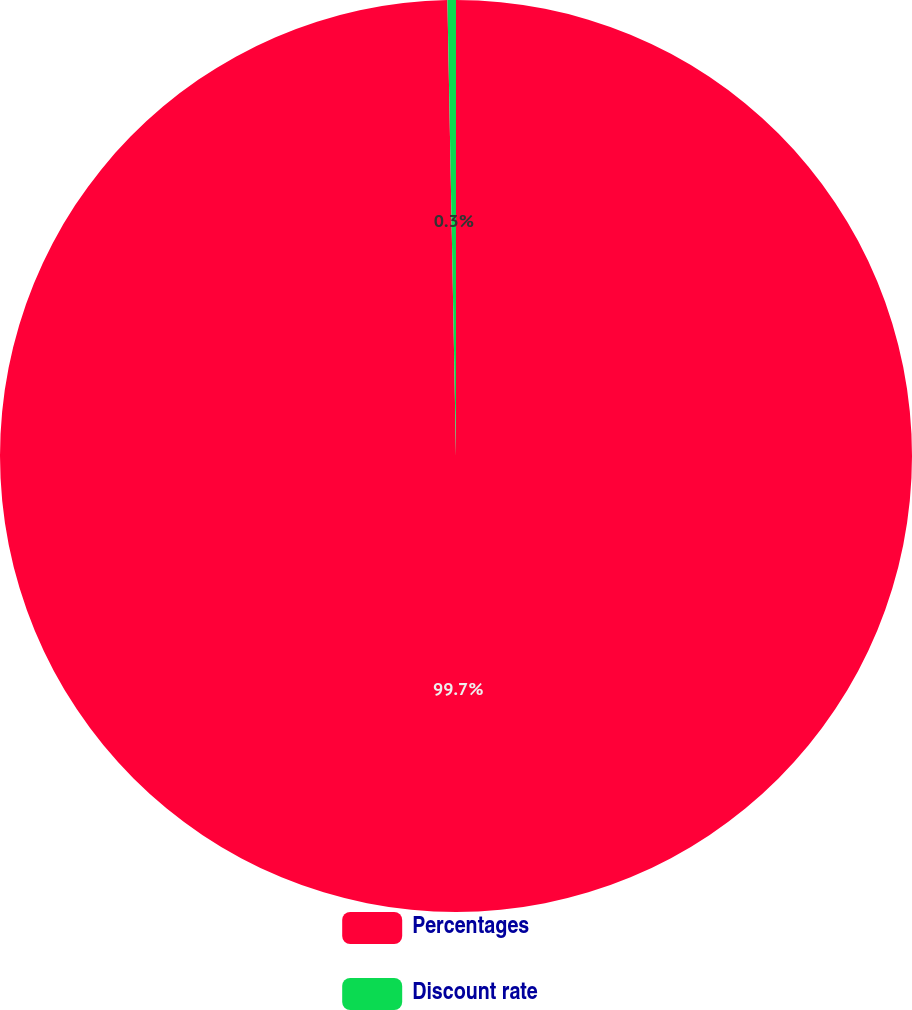Convert chart to OTSL. <chart><loc_0><loc_0><loc_500><loc_500><pie_chart><fcel>Percentages<fcel>Discount rate<nl><fcel>99.7%<fcel>0.3%<nl></chart> 